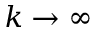Convert formula to latex. <formula><loc_0><loc_0><loc_500><loc_500>k \rightarrow \infty</formula> 